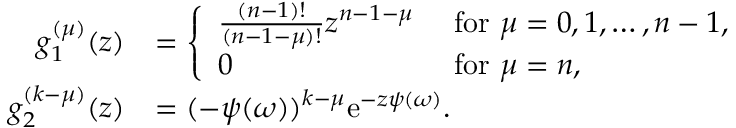<formula> <loc_0><loc_0><loc_500><loc_500>\begin{array} { r l } { g _ { 1 } ^ { ( \mu ) } ( z ) } & { = \left \{ \begin{array} { l l } { \frac { ( n - 1 ) ! } { ( n - 1 - \mu ) ! } z ^ { n - 1 - \mu } } & { f o r \mu = 0 , 1 , \dots , n - 1 , } \\ { 0 } & { f o r \mu = n , } \end{array} } \\ { g _ { 2 } ^ { ( k - \mu ) } ( z ) } & { = ( - \psi ( \omega ) ) ^ { k - \mu } \mathrm e ^ { - z \psi ( \omega ) } . } \end{array}</formula> 